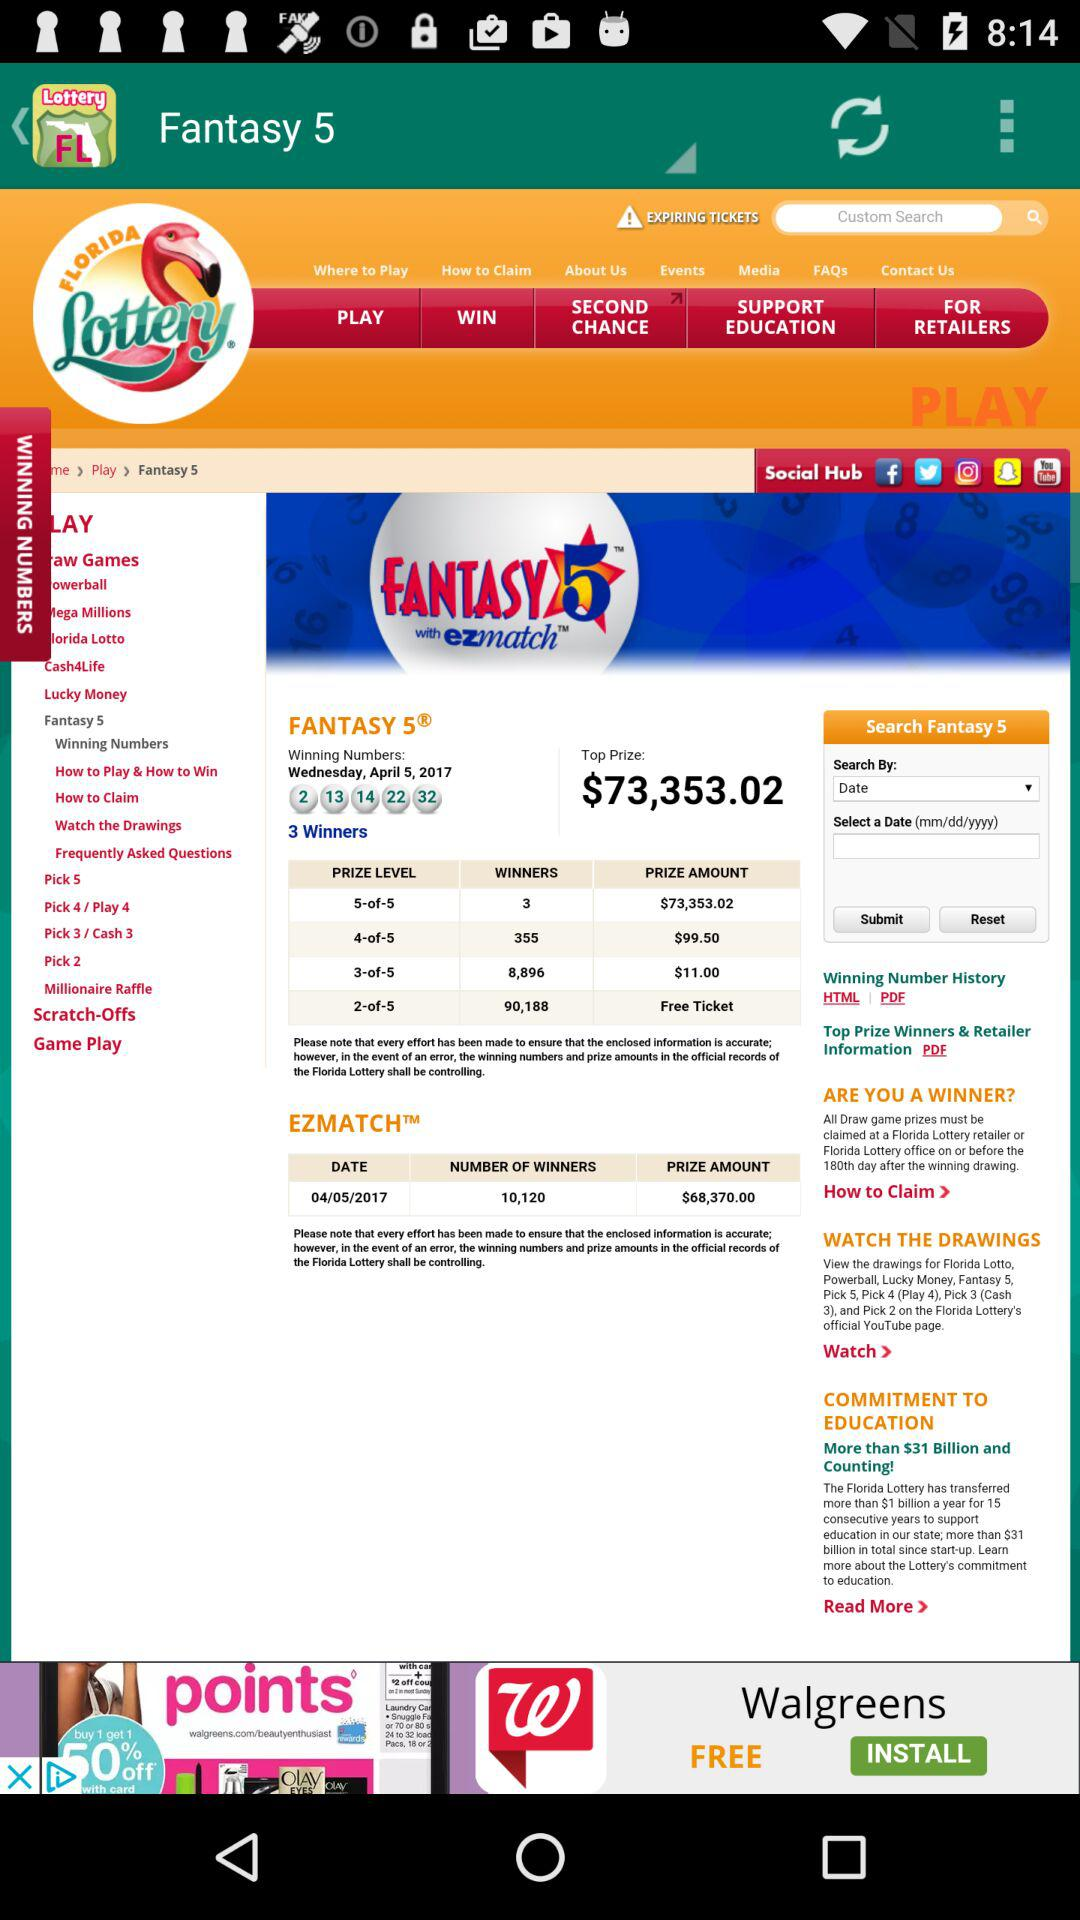How many winners are there in "EZMATCH"? There are 10,120 winners in "EZMATCH". 